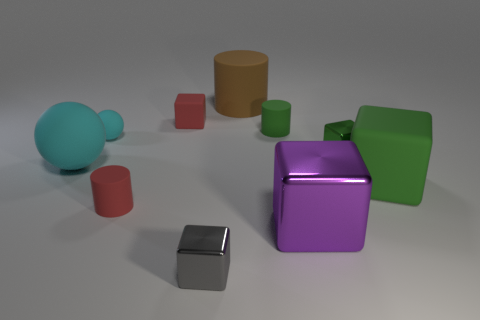How many tiny gray shiny cubes are behind the cyan matte ball on the left side of the rubber ball right of the big cyan rubber sphere?
Your answer should be very brief. 0. Does the tiny shiny cube in front of the large rubber sphere have the same color as the large rubber cylinder?
Your response must be concise. No. How many other objects are there of the same shape as the purple metallic thing?
Ensure brevity in your answer.  4. What number of other things are the same material as the green cylinder?
Your response must be concise. 6. The green object left of the tiny green cube right of the red rubber object behind the red matte cylinder is made of what material?
Make the answer very short. Rubber. Do the brown thing and the large cyan sphere have the same material?
Your answer should be compact. Yes. What number of cylinders are either matte things or large green objects?
Ensure brevity in your answer.  3. What color is the small rubber cylinder in front of the large sphere?
Offer a terse response. Red. How many matte things are either big brown objects or small red objects?
Offer a terse response. 3. What material is the cylinder to the left of the gray thing in front of the brown rubber thing?
Your answer should be very brief. Rubber. 